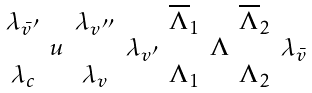<formula> <loc_0><loc_0><loc_500><loc_500>\begin{smallmatrix} \lambda _ { \bar { v } ^ { \prime } } & & \lambda _ { v ^ { \prime \prime } } & & \overline { \Lambda } _ { 1 } & & \overline { \Lambda } _ { 2 } \\ \ & u & & \lambda _ { v ^ { \prime } } & & \Lambda & & \lambda _ { \bar { v } } \\ \lambda _ { c } & & \lambda _ { v } & & \Lambda _ { 1 } & & \Lambda _ { 2 } \end{smallmatrix}</formula> 